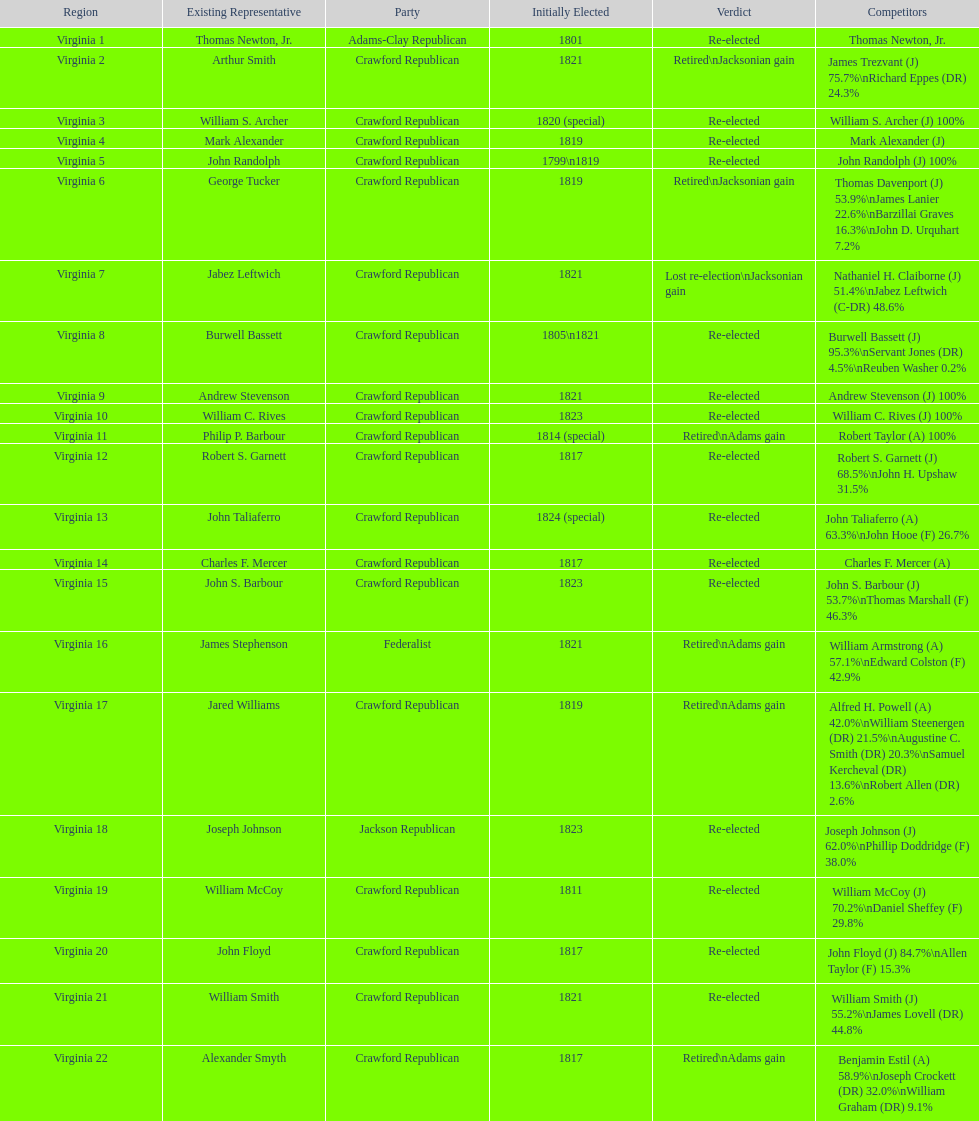How many districts are there in virginia? 22. 